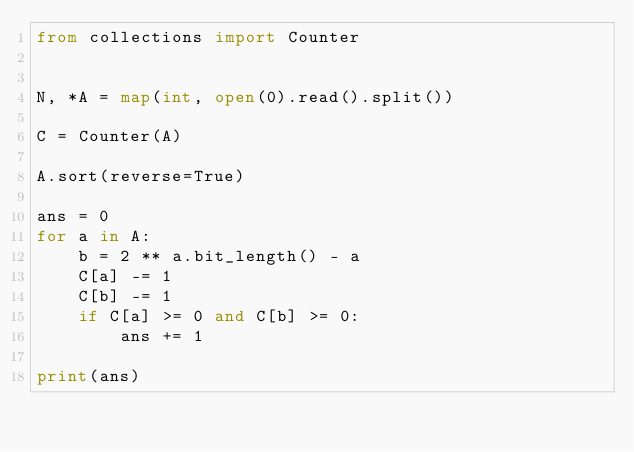Convert code to text. <code><loc_0><loc_0><loc_500><loc_500><_Python_>from collections import Counter


N, *A = map(int, open(0).read().split())

C = Counter(A)

A.sort(reverse=True)

ans = 0
for a in A:
    b = 2 ** a.bit_length() - a
    C[a] -= 1
    C[b] -= 1
    if C[a] >= 0 and C[b] >= 0:
        ans += 1

print(ans)
</code> 